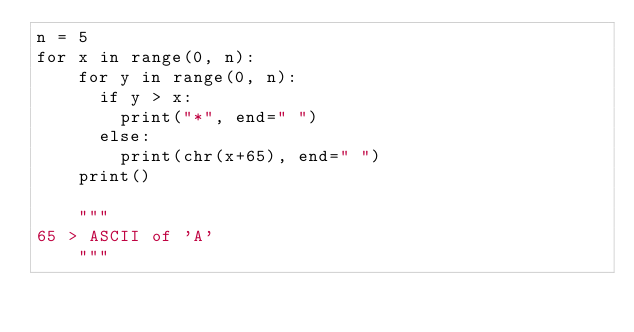<code> <loc_0><loc_0><loc_500><loc_500><_Python_>n = 5
for x in range(0, n):
    for y in range(0, n):
      if y > x:
        print("*", end=" ")
      else:
        print(chr(x+65), end=" ")
    print()

    """
65 > ASCII of 'A'
    """</code> 